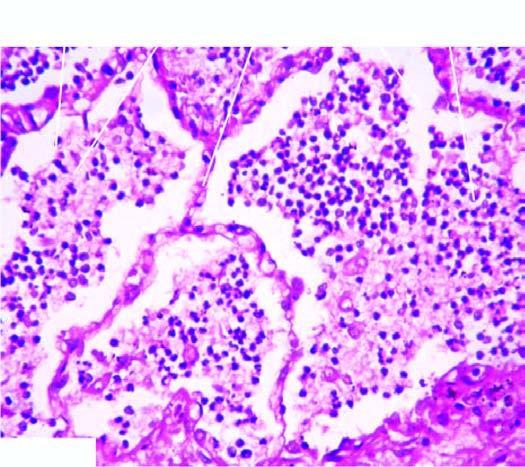s salt bridges lying separated from the septal walls by a clear space?
Answer the question using a single word or phrase. No 